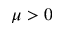Convert formula to latex. <formula><loc_0><loc_0><loc_500><loc_500>\mu > 0</formula> 